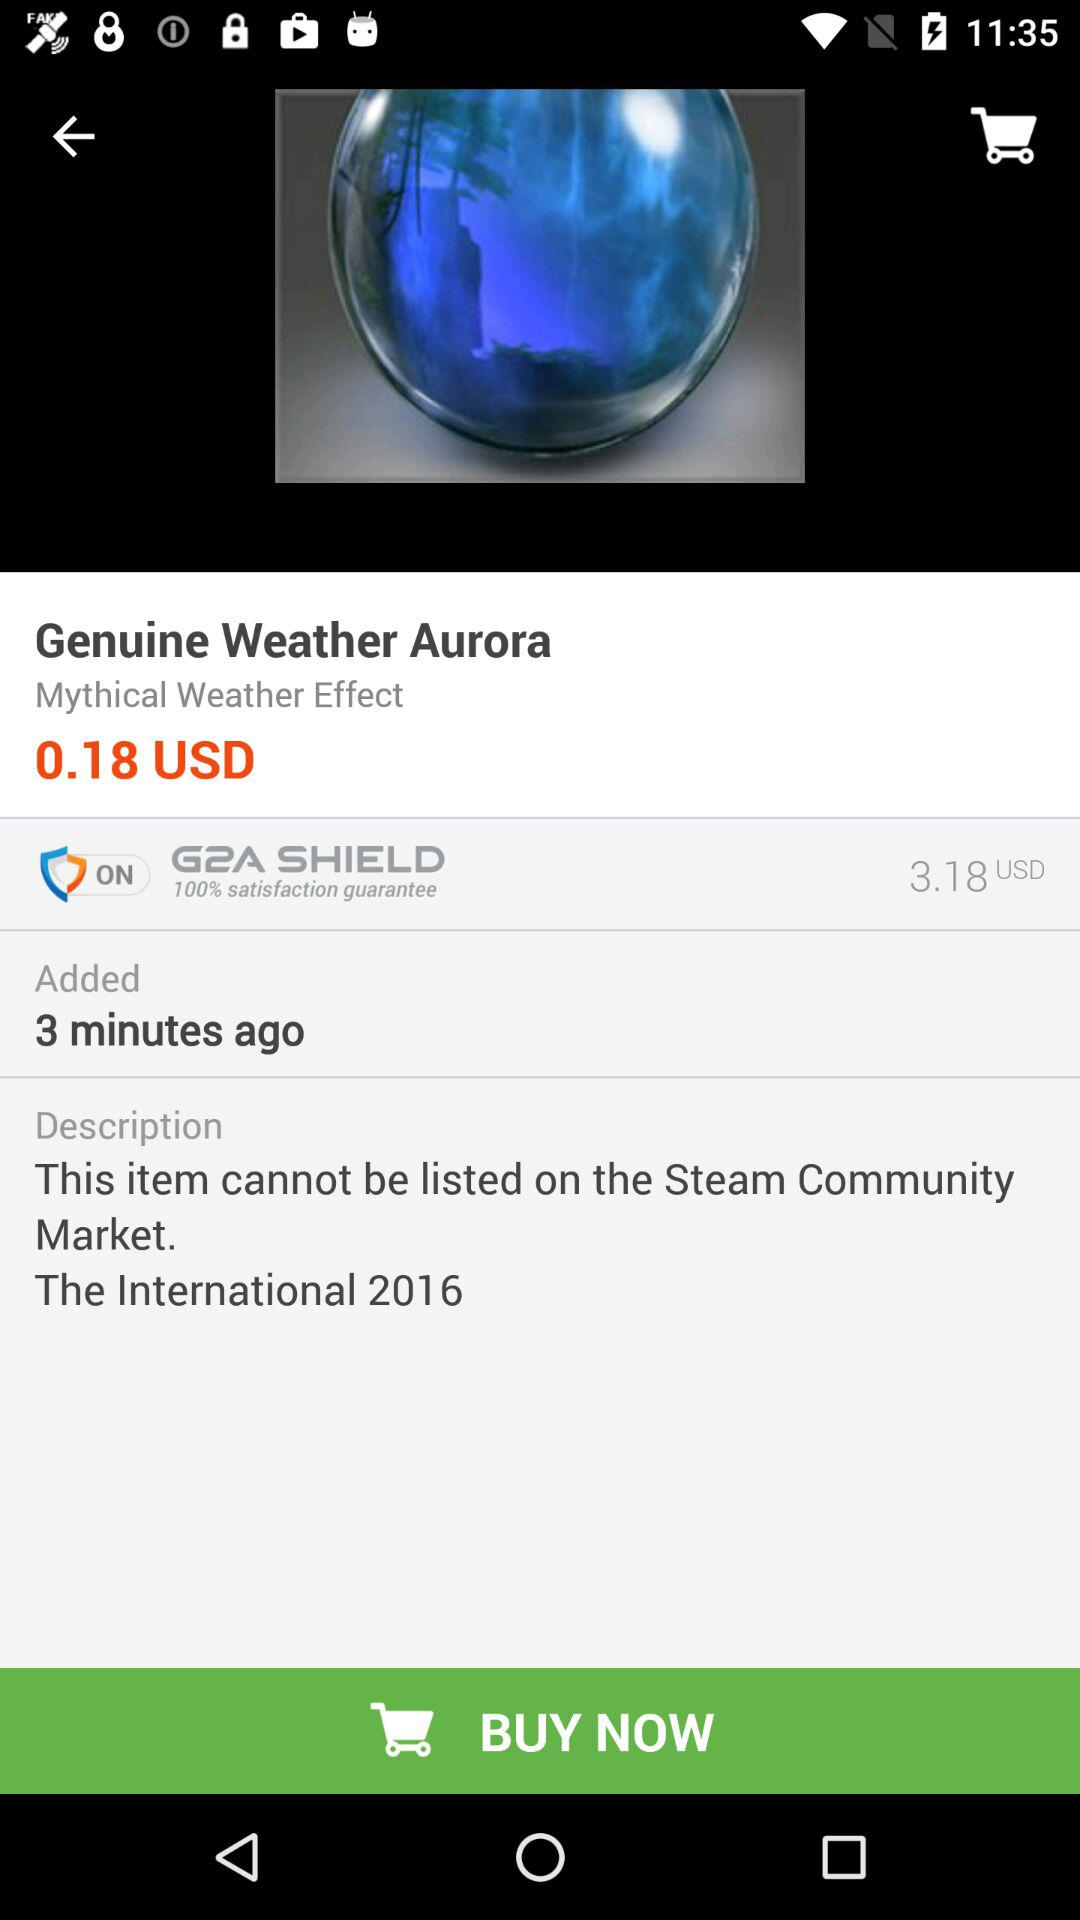Is there any Item added on the cart?
When the provided information is insufficient, respond with <no answer>. <no answer> 